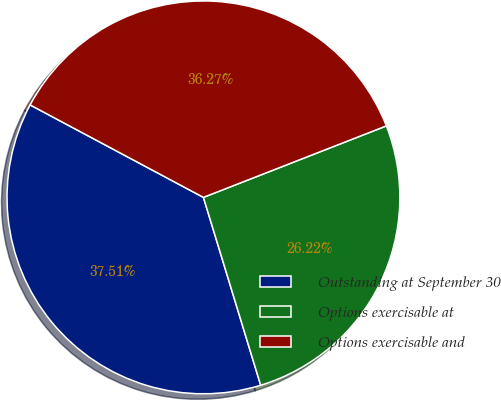Convert chart. <chart><loc_0><loc_0><loc_500><loc_500><pie_chart><fcel>Outstanding at September 30<fcel>Options exercisable at<fcel>Options exercisable and<nl><fcel>37.51%<fcel>26.22%<fcel>36.27%<nl></chart> 